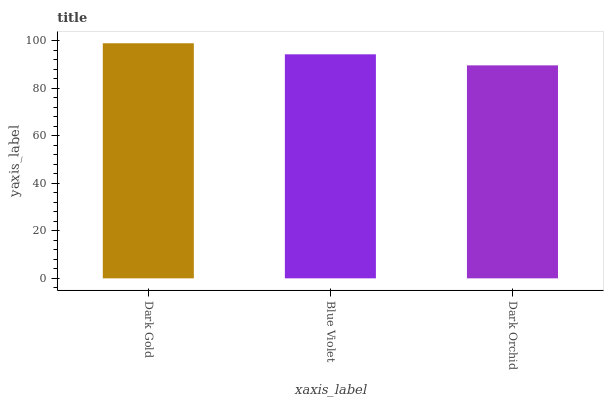Is Dark Orchid the minimum?
Answer yes or no. Yes. Is Dark Gold the maximum?
Answer yes or no. Yes. Is Blue Violet the minimum?
Answer yes or no. No. Is Blue Violet the maximum?
Answer yes or no. No. Is Dark Gold greater than Blue Violet?
Answer yes or no. Yes. Is Blue Violet less than Dark Gold?
Answer yes or no. Yes. Is Blue Violet greater than Dark Gold?
Answer yes or no. No. Is Dark Gold less than Blue Violet?
Answer yes or no. No. Is Blue Violet the high median?
Answer yes or no. Yes. Is Blue Violet the low median?
Answer yes or no. Yes. Is Dark Orchid the high median?
Answer yes or no. No. Is Dark Gold the low median?
Answer yes or no. No. 